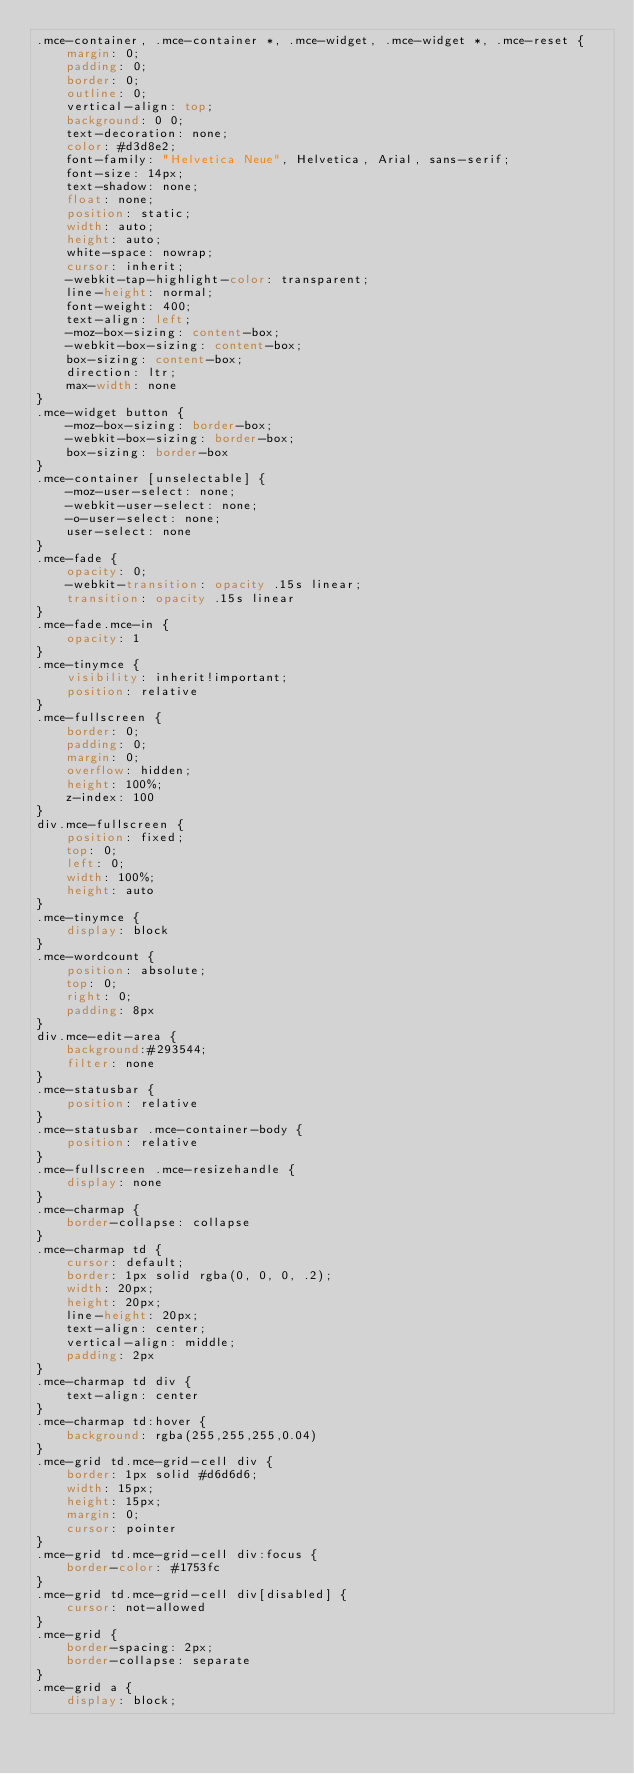Convert code to text. <code><loc_0><loc_0><loc_500><loc_500><_CSS_>.mce-container, .mce-container *, .mce-widget, .mce-widget *, .mce-reset {
	margin: 0;
	padding: 0;
	border: 0;
	outline: 0;
	vertical-align: top;
	background: 0 0;
	text-decoration: none;
	color: #d3d8e2;
	font-family: "Helvetica Neue", Helvetica, Arial, sans-serif;
	font-size: 14px;
	text-shadow: none;
	float: none;
	position: static;
	width: auto;
	height: auto;
	white-space: nowrap;
	cursor: inherit;
	-webkit-tap-highlight-color: transparent;
	line-height: normal;
	font-weight: 400;
	text-align: left;
	-moz-box-sizing: content-box;
	-webkit-box-sizing: content-box;
	box-sizing: content-box;
	direction: ltr;
	max-width: none
}
.mce-widget button {
	-moz-box-sizing: border-box;
	-webkit-box-sizing: border-box;
	box-sizing: border-box
}
.mce-container [unselectable] {
	-moz-user-select: none;
	-webkit-user-select: none;
	-o-user-select: none;
	user-select: none
}
.mce-fade {
	opacity: 0;
	-webkit-transition: opacity .15s linear;
	transition: opacity .15s linear
}
.mce-fade.mce-in {
	opacity: 1
}
.mce-tinymce {
	visibility: inherit!important;
	position: relative
}
.mce-fullscreen {
	border: 0;
	padding: 0;
	margin: 0;
	overflow: hidden;
	height: 100%;
	z-index: 100
}
div.mce-fullscreen {
	position: fixed;
	top: 0;
	left: 0;
	width: 100%;
	height: auto
}
.mce-tinymce {
	display: block
}
.mce-wordcount {
	position: absolute;
	top: 0;
	right: 0;
	padding: 8px
}
div.mce-edit-area {
	background:#293544;
	filter: none
}
.mce-statusbar {
	position: relative
}
.mce-statusbar .mce-container-body {
	position: relative
}
.mce-fullscreen .mce-resizehandle {
	display: none
}
.mce-charmap {
	border-collapse: collapse
}
.mce-charmap td {
	cursor: default;
	border: 1px solid rgba(0, 0, 0, .2);
	width: 20px;
	height: 20px;
	line-height: 20px;
	text-align: center;
	vertical-align: middle;
	padding: 2px
}
.mce-charmap td div {
	text-align: center
}
.mce-charmap td:hover {
	background: rgba(255,255,255,0.04)
}
.mce-grid td.mce-grid-cell div {
	border: 1px solid #d6d6d6;
	width: 15px;
	height: 15px;
	margin: 0;
	cursor: pointer
}
.mce-grid td.mce-grid-cell div:focus {
	border-color: #1753fc
}
.mce-grid td.mce-grid-cell div[disabled] {
	cursor: not-allowed
}
.mce-grid {
	border-spacing: 2px;
	border-collapse: separate
}
.mce-grid a {
	display: block;</code> 